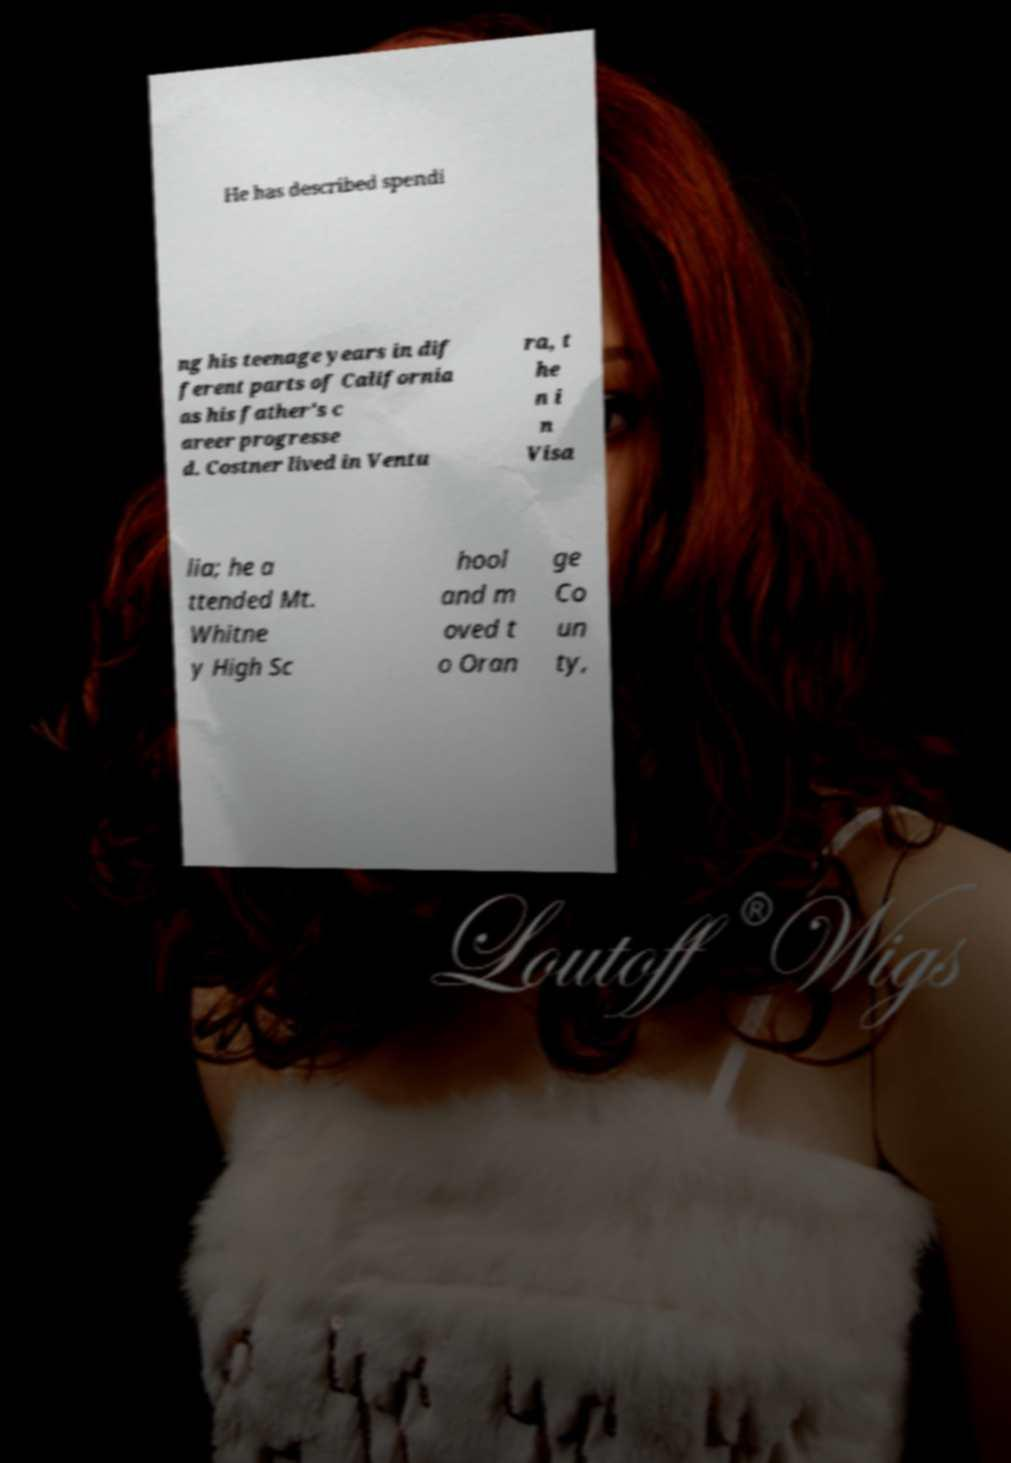There's text embedded in this image that I need extracted. Can you transcribe it verbatim? He has described spendi ng his teenage years in dif ferent parts of California as his father's c areer progresse d. Costner lived in Ventu ra, t he n i n Visa lia; he a ttended Mt. Whitne y High Sc hool and m oved t o Oran ge Co un ty, 